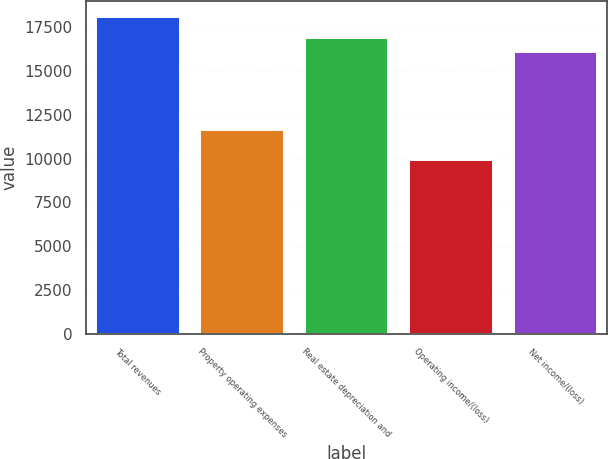Convert chart. <chart><loc_0><loc_0><loc_500><loc_500><bar_chart><fcel>Total revenues<fcel>Property operating expenses<fcel>Real estate depreciation and<fcel>Operating income/(loss)<fcel>Net income/(loss)<nl><fcel>18090<fcel>11655<fcel>16899.2<fcel>9918<fcel>16082<nl></chart> 